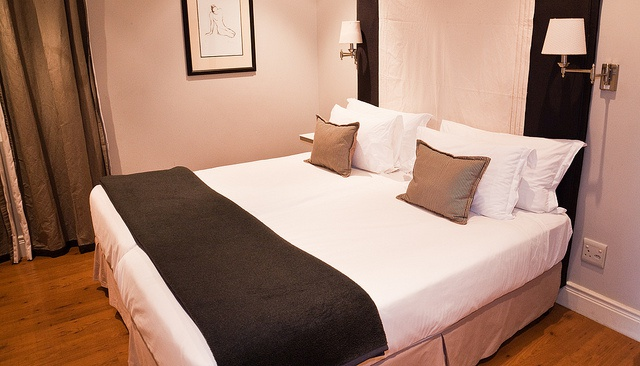Describe the objects in this image and their specific colors. I can see a bed in gray, lightgray, black, maroon, and brown tones in this image. 